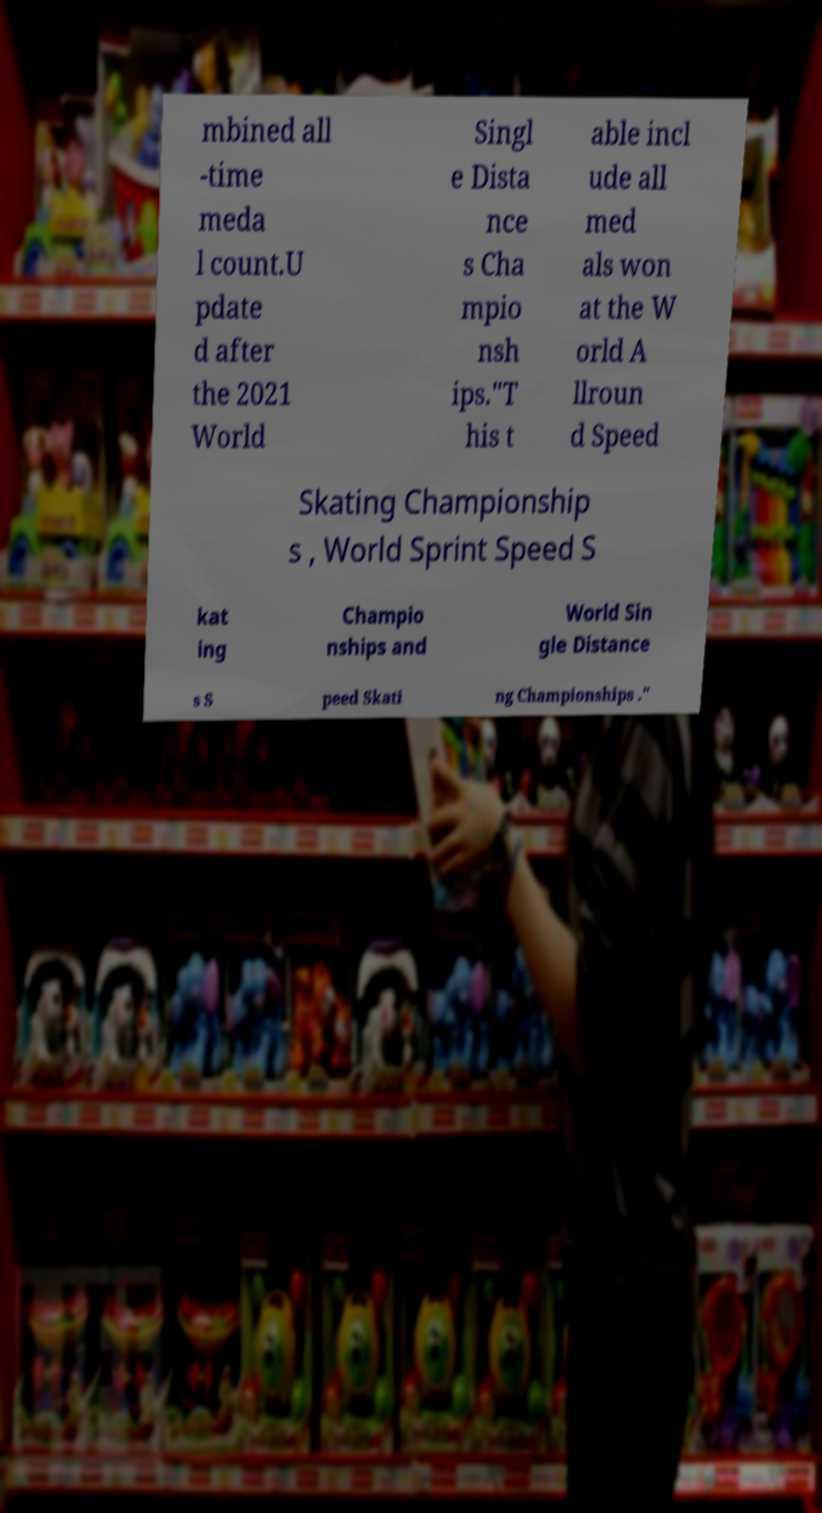Please identify and transcribe the text found in this image. mbined all -time meda l count.U pdate d after the 2021 World Singl e Dista nce s Cha mpio nsh ips."T his t able incl ude all med als won at the W orld A llroun d Speed Skating Championship s , World Sprint Speed S kat ing Champio nships and World Sin gle Distance s S peed Skati ng Championships ." 